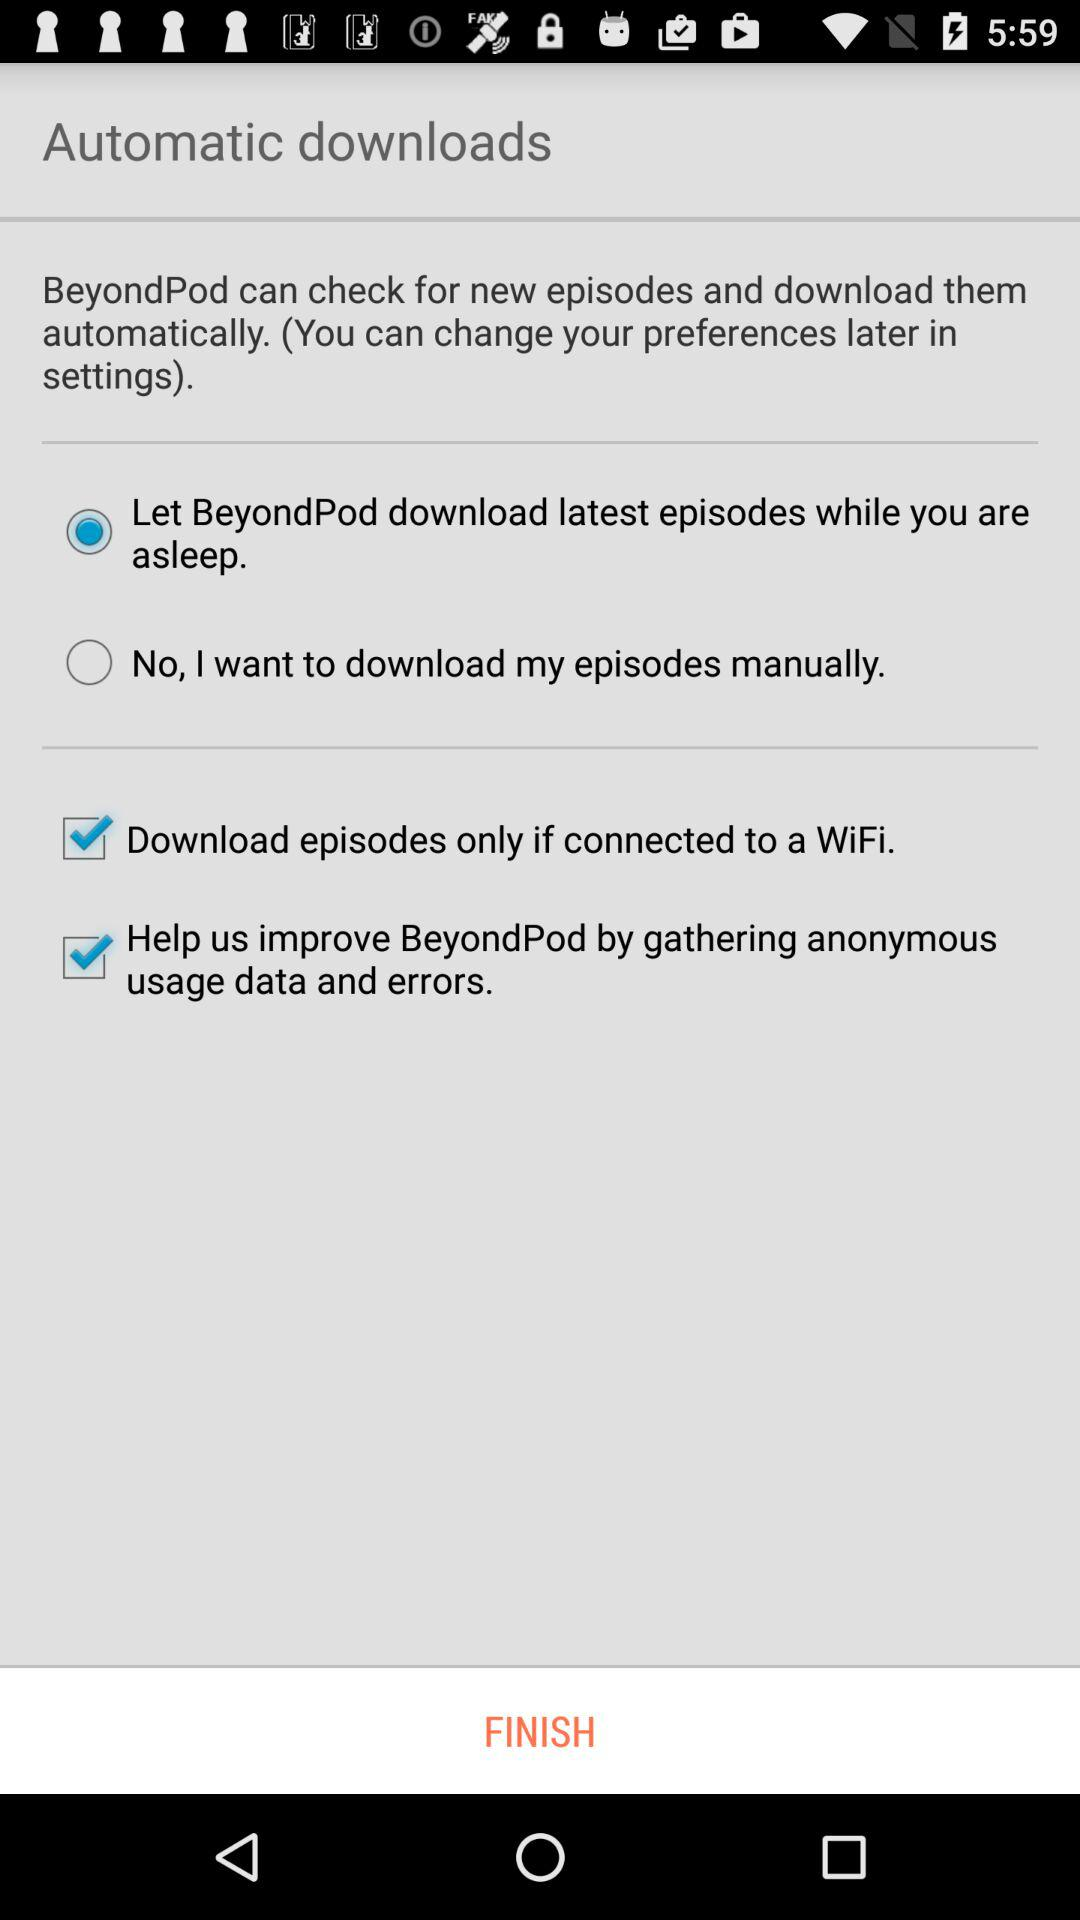What's the status of "Download episodes only if connected to a WiFi"? The status of "Download episodes only if connected to a WiFi" is "on". 